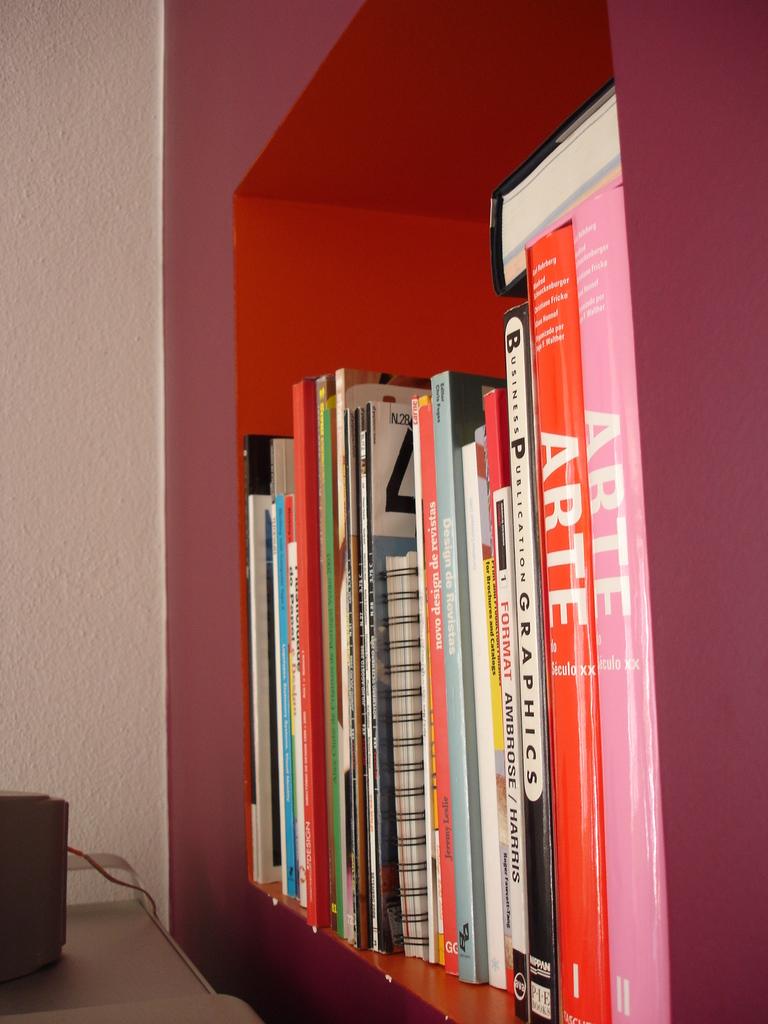What are the titles of the red and pink books on the right edge?
Make the answer very short. Arte. 